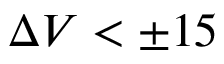<formula> <loc_0><loc_0><loc_500><loc_500>\Delta V < \pm 1 5</formula> 